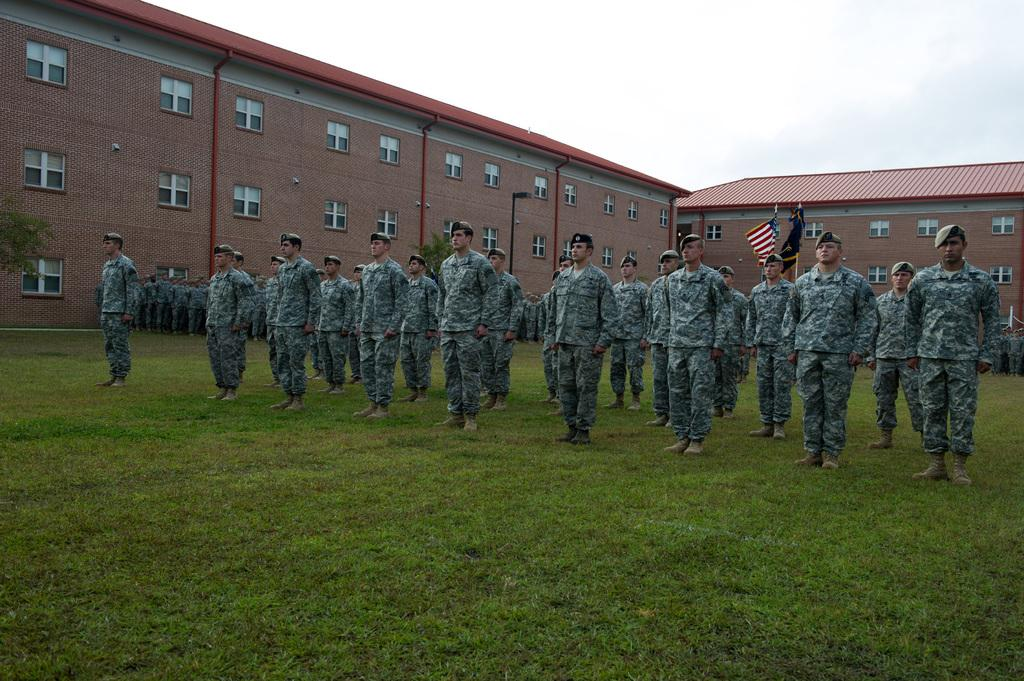What can be seen in the image? There is a group of people in the image. What are the people wearing? The people are wearing military uniforms. Where are the people standing? The people are standing on the grass. What can be seen in the background of the image? There are buildings, flags, and a pole in the background of the image. What type of reward is the group of people receiving in the image? There is no indication in the image that the group of people is receiving any reward. 